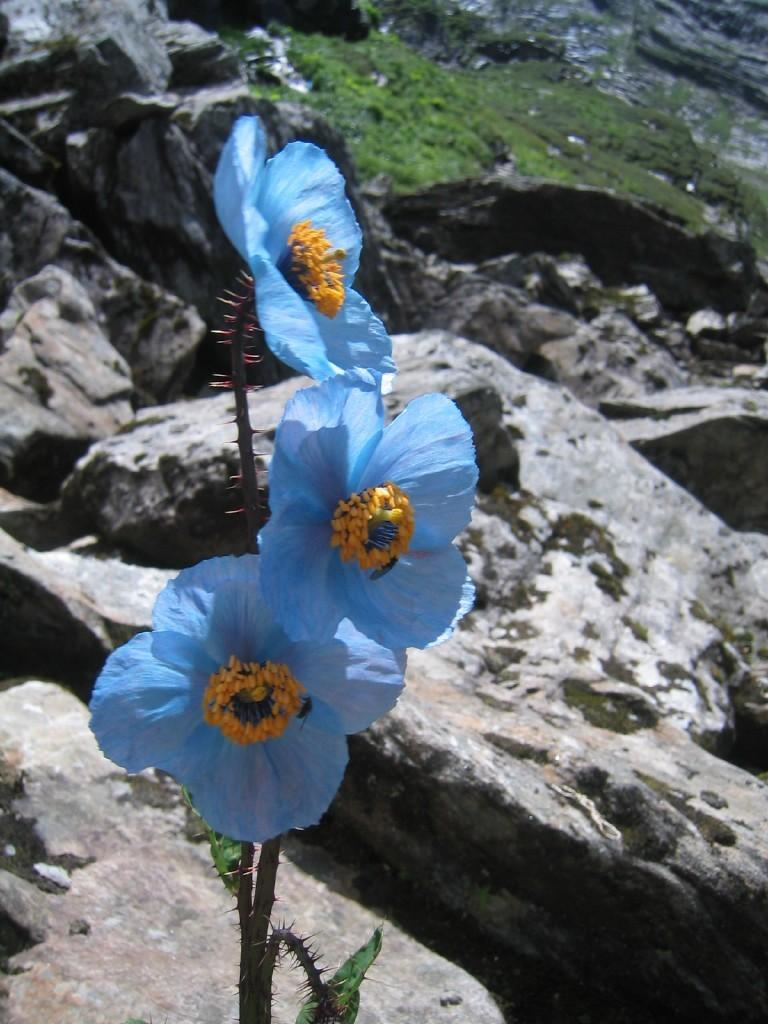What type of plants can be seen in the image? There are flowers in the image. What colors are the flowers? The flowers are blue, yellow, and green in color. Where are the flowers located? The flowers are on a plant. What can be seen in the background of the image? There are rocks in the background of the image. What type of vegetation is on the rocks? There is grass on the rocks in the background. What type of hill can be seen in the background of the image? There is no hill present in the image; it features flowers on a plant, rocks, and grass in the background. 